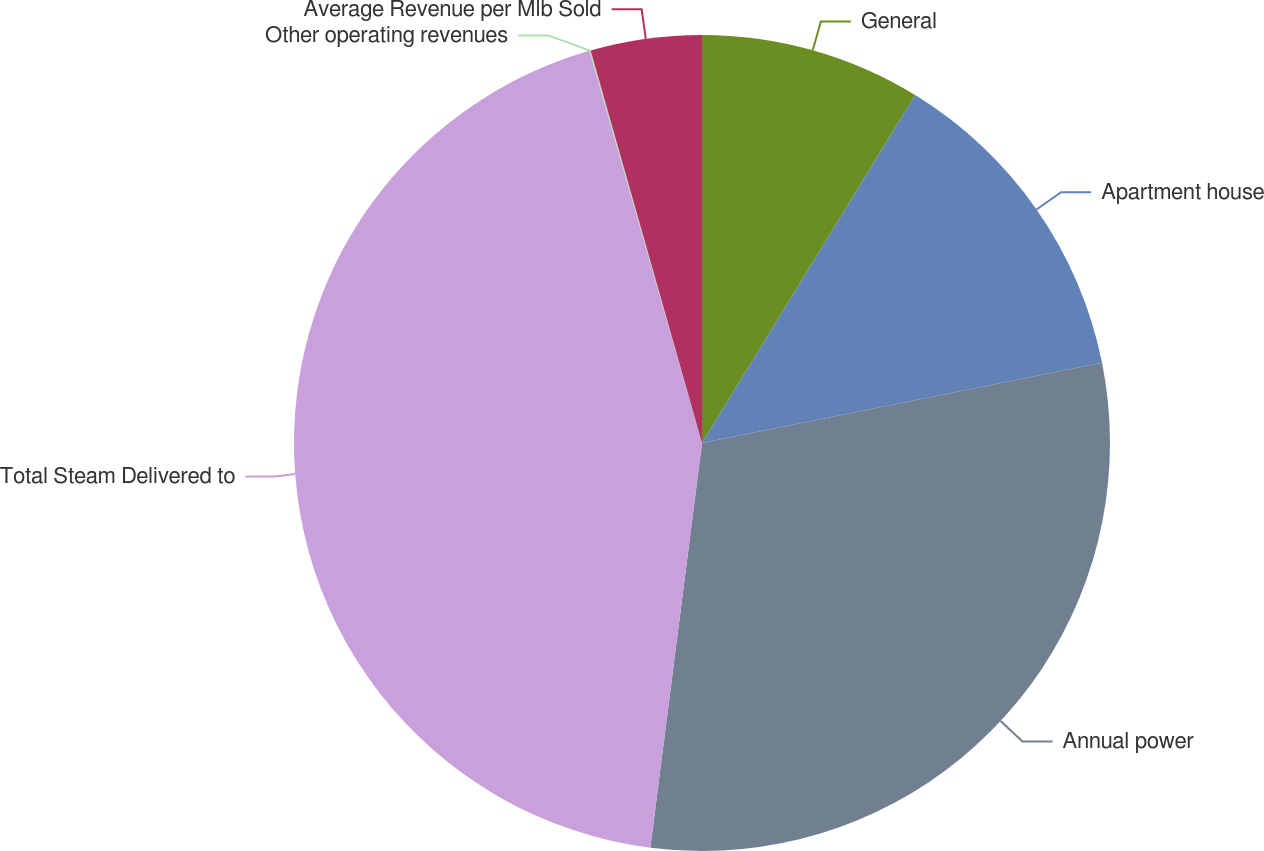<chart> <loc_0><loc_0><loc_500><loc_500><pie_chart><fcel>General<fcel>Apartment house<fcel>Annual power<fcel>Total Steam Delivered to<fcel>Other operating revenues<fcel>Average Revenue per Mlb Sold<nl><fcel>8.75%<fcel>13.1%<fcel>30.17%<fcel>43.53%<fcel>0.05%<fcel>4.4%<nl></chart> 